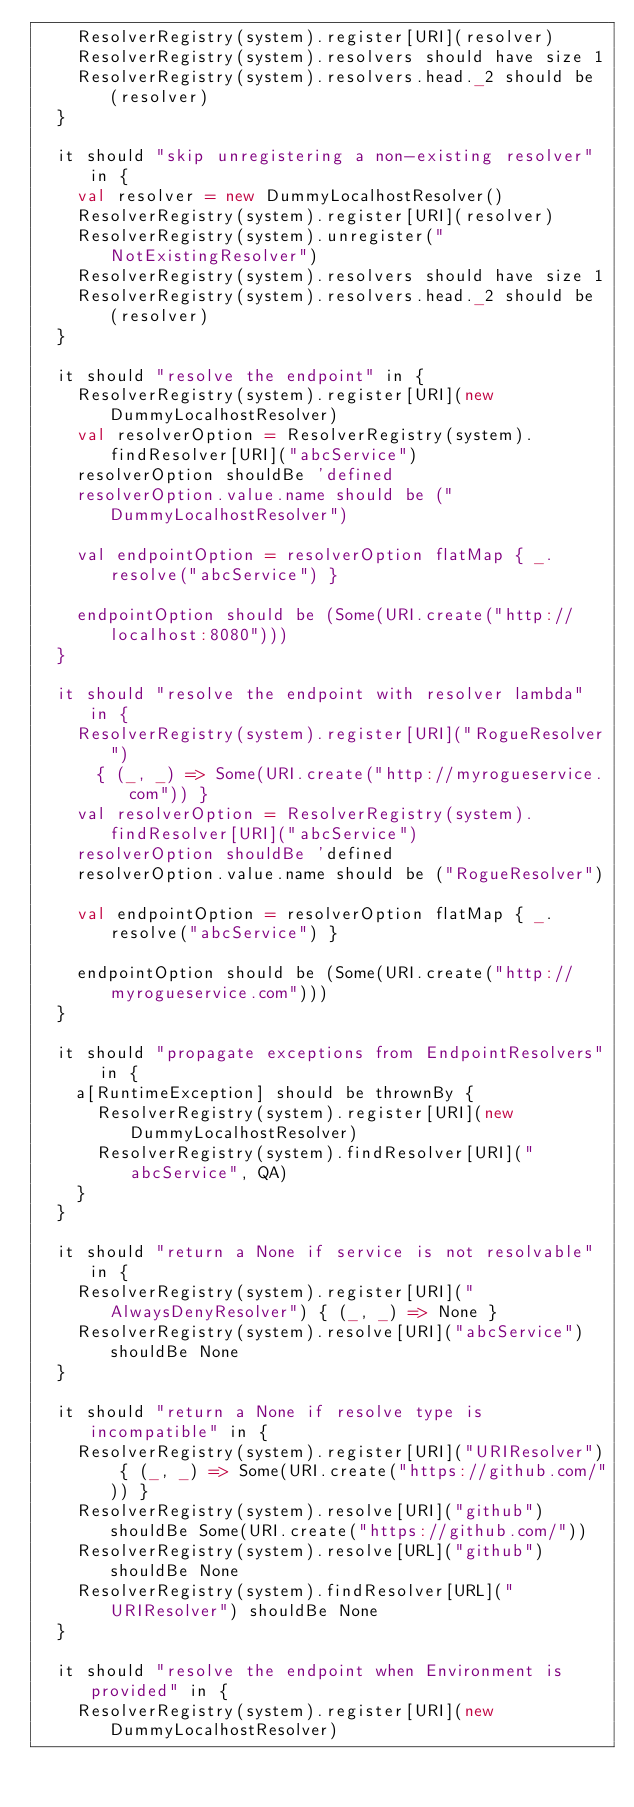<code> <loc_0><loc_0><loc_500><loc_500><_Scala_>    ResolverRegistry(system).register[URI](resolver)
    ResolverRegistry(system).resolvers should have size 1
    ResolverRegistry(system).resolvers.head._2 should be (resolver)
  }

  it should "skip unregistering a non-existing resolver" in {
    val resolver = new DummyLocalhostResolver()
    ResolverRegistry(system).register[URI](resolver)
    ResolverRegistry(system).unregister("NotExistingResolver")
    ResolverRegistry(system).resolvers should have size 1
    ResolverRegistry(system).resolvers.head._2 should be (resolver)
  }

  it should "resolve the endpoint" in {
    ResolverRegistry(system).register[URI](new DummyLocalhostResolver)
    val resolverOption = ResolverRegistry(system).findResolver[URI]("abcService")
    resolverOption shouldBe 'defined
    resolverOption.value.name should be ("DummyLocalhostResolver")

    val endpointOption = resolverOption flatMap { _.resolve("abcService") }

    endpointOption should be (Some(URI.create("http://localhost:8080")))
  }

  it should "resolve the endpoint with resolver lambda" in {
    ResolverRegistry(system).register[URI]("RogueResolver")
      { (_, _) => Some(URI.create("http://myrogueservice.com")) }
    val resolverOption = ResolverRegistry(system).findResolver[URI]("abcService")
    resolverOption shouldBe 'defined
    resolverOption.value.name should be ("RogueResolver")

    val endpointOption = resolverOption flatMap { _.resolve("abcService") }

    endpointOption should be (Some(URI.create("http://myrogueservice.com")))
  }

  it should "propagate exceptions from EndpointResolvers" in {
    a[RuntimeException] should be thrownBy {
      ResolverRegistry(system).register[URI](new DummyLocalhostResolver)
      ResolverRegistry(system).findResolver[URI]("abcService", QA)
    }
  }

  it should "return a None if service is not resolvable" in {
    ResolverRegistry(system).register[URI]("AlwaysDenyResolver") { (_, _) => None }
    ResolverRegistry(system).resolve[URI]("abcService") shouldBe None
  }

  it should "return a None if resolve type is incompatible" in {
    ResolverRegistry(system).register[URI]("URIResolver") { (_, _) => Some(URI.create("https://github.com/")) }
    ResolverRegistry(system).resolve[URI]("github") shouldBe Some(URI.create("https://github.com/"))
    ResolverRegistry(system).resolve[URL]("github") shouldBe None
    ResolverRegistry(system).findResolver[URL]("URIResolver") shouldBe None
  }

  it should "resolve the endpoint when Environment is provided" in {
    ResolverRegistry(system).register[URI](new DummyLocalhostResolver)</code> 